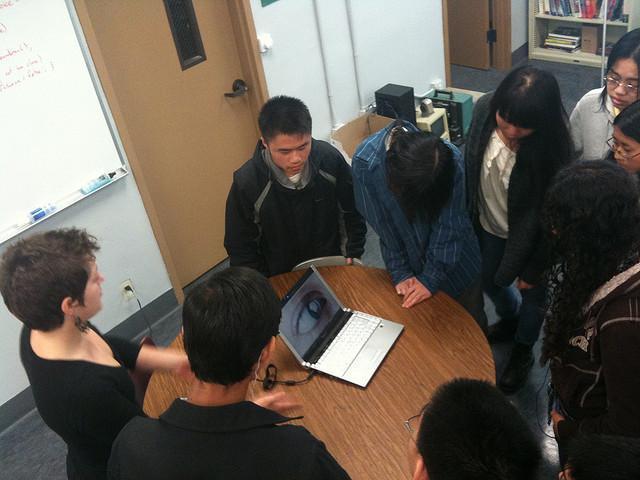How many people are in the photo?
Give a very brief answer. 8. 